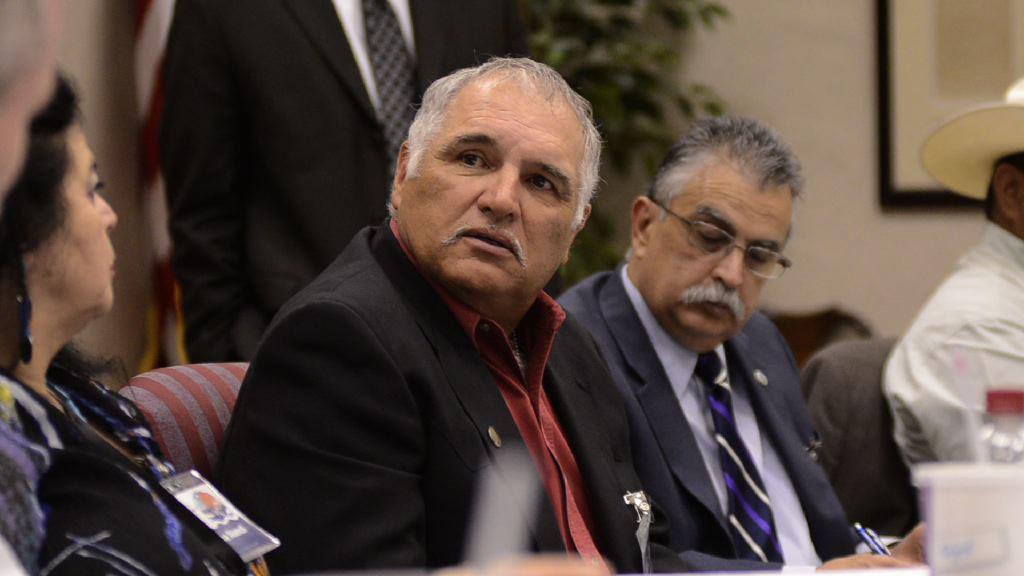Describe this image in one or two sentences. In this image we can see some group of persons wearing suits sitting on chairs holding pens in their hands and in the background of the image we can see a person wearing black color suit standing there is plant and there is a wall. 